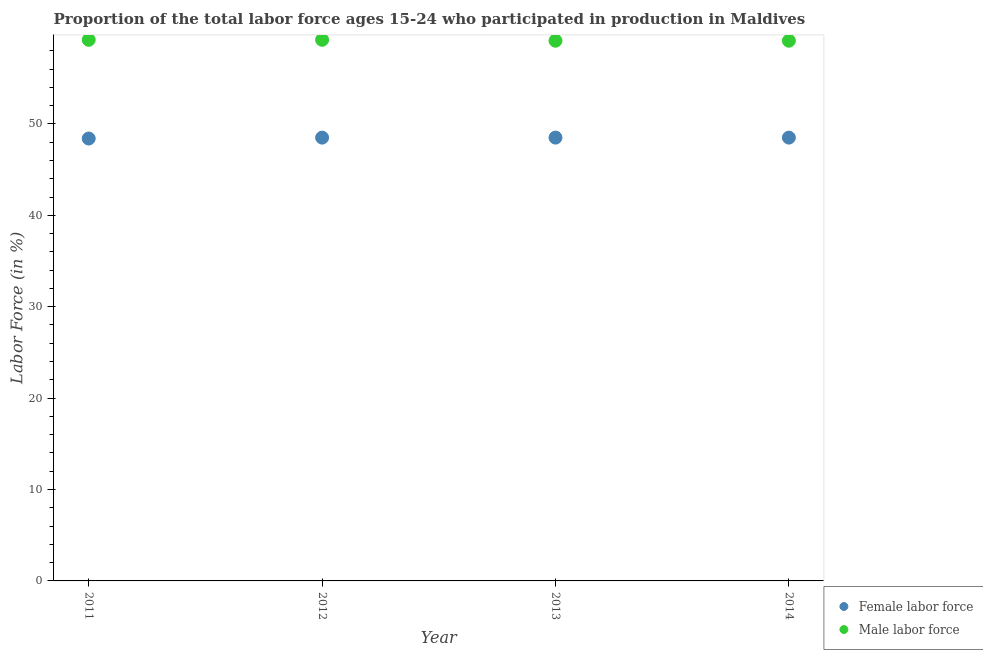How many different coloured dotlines are there?
Your response must be concise. 2. What is the percentage of female labor force in 2011?
Provide a succinct answer. 48.4. Across all years, what is the maximum percentage of male labour force?
Make the answer very short. 59.2. Across all years, what is the minimum percentage of female labor force?
Provide a succinct answer. 48.4. In which year was the percentage of male labour force maximum?
Provide a succinct answer. 2011. In which year was the percentage of female labor force minimum?
Your answer should be very brief. 2011. What is the total percentage of female labor force in the graph?
Offer a very short reply. 193.9. What is the difference between the percentage of male labour force in 2011 and the percentage of female labor force in 2012?
Give a very brief answer. 10.7. What is the average percentage of female labor force per year?
Offer a terse response. 48.48. In the year 2012, what is the difference between the percentage of male labour force and percentage of female labor force?
Make the answer very short. 10.7. Is the percentage of male labour force in 2011 less than that in 2012?
Provide a short and direct response. No. Is the difference between the percentage of male labour force in 2012 and 2014 greater than the difference between the percentage of female labor force in 2012 and 2014?
Give a very brief answer. Yes. What is the difference between the highest and the lowest percentage of female labor force?
Your response must be concise. 0.1. Is the sum of the percentage of male labour force in 2011 and 2013 greater than the maximum percentage of female labor force across all years?
Provide a short and direct response. Yes. Is the percentage of male labour force strictly greater than the percentage of female labor force over the years?
Give a very brief answer. Yes. Is the percentage of male labour force strictly less than the percentage of female labor force over the years?
Provide a short and direct response. No. How many dotlines are there?
Provide a short and direct response. 2. What is the difference between two consecutive major ticks on the Y-axis?
Give a very brief answer. 10. Does the graph contain any zero values?
Your answer should be very brief. No. Does the graph contain grids?
Offer a very short reply. No. How many legend labels are there?
Keep it short and to the point. 2. How are the legend labels stacked?
Your answer should be compact. Vertical. What is the title of the graph?
Keep it short and to the point. Proportion of the total labor force ages 15-24 who participated in production in Maldives. What is the Labor Force (in %) of Female labor force in 2011?
Provide a succinct answer. 48.4. What is the Labor Force (in %) of Male labor force in 2011?
Your answer should be very brief. 59.2. What is the Labor Force (in %) of Female labor force in 2012?
Your response must be concise. 48.5. What is the Labor Force (in %) of Male labor force in 2012?
Provide a short and direct response. 59.2. What is the Labor Force (in %) of Female labor force in 2013?
Give a very brief answer. 48.5. What is the Labor Force (in %) of Male labor force in 2013?
Give a very brief answer. 59.1. What is the Labor Force (in %) in Female labor force in 2014?
Your answer should be very brief. 48.5. What is the Labor Force (in %) of Male labor force in 2014?
Give a very brief answer. 59.1. Across all years, what is the maximum Labor Force (in %) of Female labor force?
Your answer should be compact. 48.5. Across all years, what is the maximum Labor Force (in %) of Male labor force?
Give a very brief answer. 59.2. Across all years, what is the minimum Labor Force (in %) of Female labor force?
Make the answer very short. 48.4. Across all years, what is the minimum Labor Force (in %) in Male labor force?
Provide a succinct answer. 59.1. What is the total Labor Force (in %) in Female labor force in the graph?
Keep it short and to the point. 193.9. What is the total Labor Force (in %) in Male labor force in the graph?
Ensure brevity in your answer.  236.6. What is the difference between the Labor Force (in %) of Female labor force in 2011 and that in 2012?
Give a very brief answer. -0.1. What is the difference between the Labor Force (in %) of Female labor force in 2011 and that in 2013?
Make the answer very short. -0.1. What is the difference between the Labor Force (in %) of Female labor force in 2011 and that in 2014?
Provide a succinct answer. -0.1. What is the difference between the Labor Force (in %) of Female labor force in 2011 and the Labor Force (in %) of Male labor force in 2013?
Give a very brief answer. -10.7. What is the difference between the Labor Force (in %) of Female labor force in 2012 and the Labor Force (in %) of Male labor force in 2013?
Keep it short and to the point. -10.6. What is the difference between the Labor Force (in %) of Female labor force in 2012 and the Labor Force (in %) of Male labor force in 2014?
Your response must be concise. -10.6. What is the difference between the Labor Force (in %) in Female labor force in 2013 and the Labor Force (in %) in Male labor force in 2014?
Your response must be concise. -10.6. What is the average Labor Force (in %) of Female labor force per year?
Ensure brevity in your answer.  48.48. What is the average Labor Force (in %) in Male labor force per year?
Offer a very short reply. 59.15. In the year 2012, what is the difference between the Labor Force (in %) of Female labor force and Labor Force (in %) of Male labor force?
Make the answer very short. -10.7. What is the ratio of the Labor Force (in %) of Female labor force in 2011 to that in 2012?
Provide a short and direct response. 1. What is the ratio of the Labor Force (in %) in Female labor force in 2011 to that in 2013?
Ensure brevity in your answer.  1. What is the ratio of the Labor Force (in %) in Female labor force in 2012 to that in 2013?
Your response must be concise. 1. What is the ratio of the Labor Force (in %) of Male labor force in 2013 to that in 2014?
Give a very brief answer. 1. What is the difference between the highest and the lowest Labor Force (in %) in Female labor force?
Offer a terse response. 0.1. What is the difference between the highest and the lowest Labor Force (in %) in Male labor force?
Your response must be concise. 0.1. 